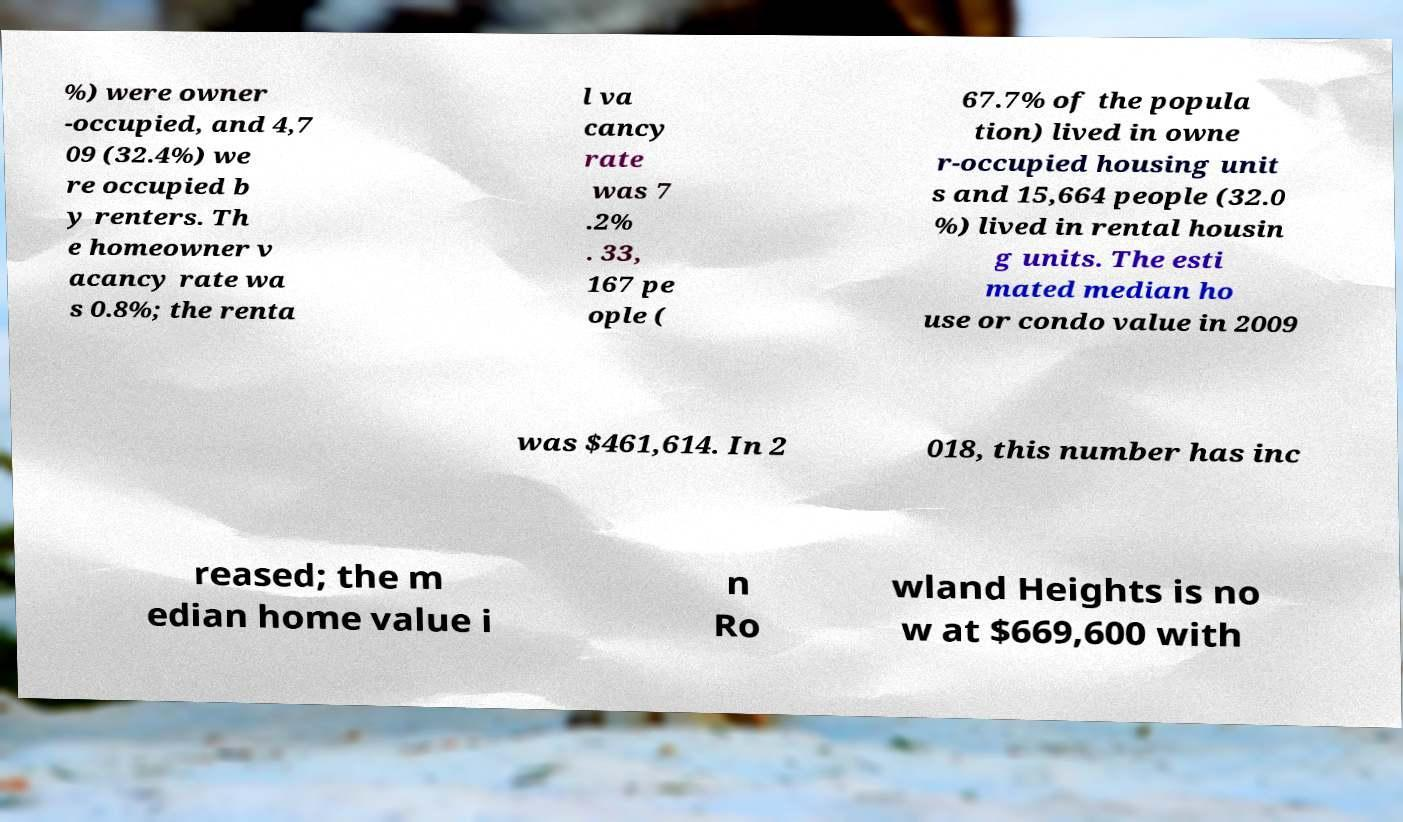There's text embedded in this image that I need extracted. Can you transcribe it verbatim? %) were owner -occupied, and 4,7 09 (32.4%) we re occupied b y renters. Th e homeowner v acancy rate wa s 0.8%; the renta l va cancy rate was 7 .2% . 33, 167 pe ople ( 67.7% of the popula tion) lived in owne r-occupied housing unit s and 15,664 people (32.0 %) lived in rental housin g units. The esti mated median ho use or condo value in 2009 was $461,614. In 2 018, this number has inc reased; the m edian home value i n Ro wland Heights is no w at $669,600 with 